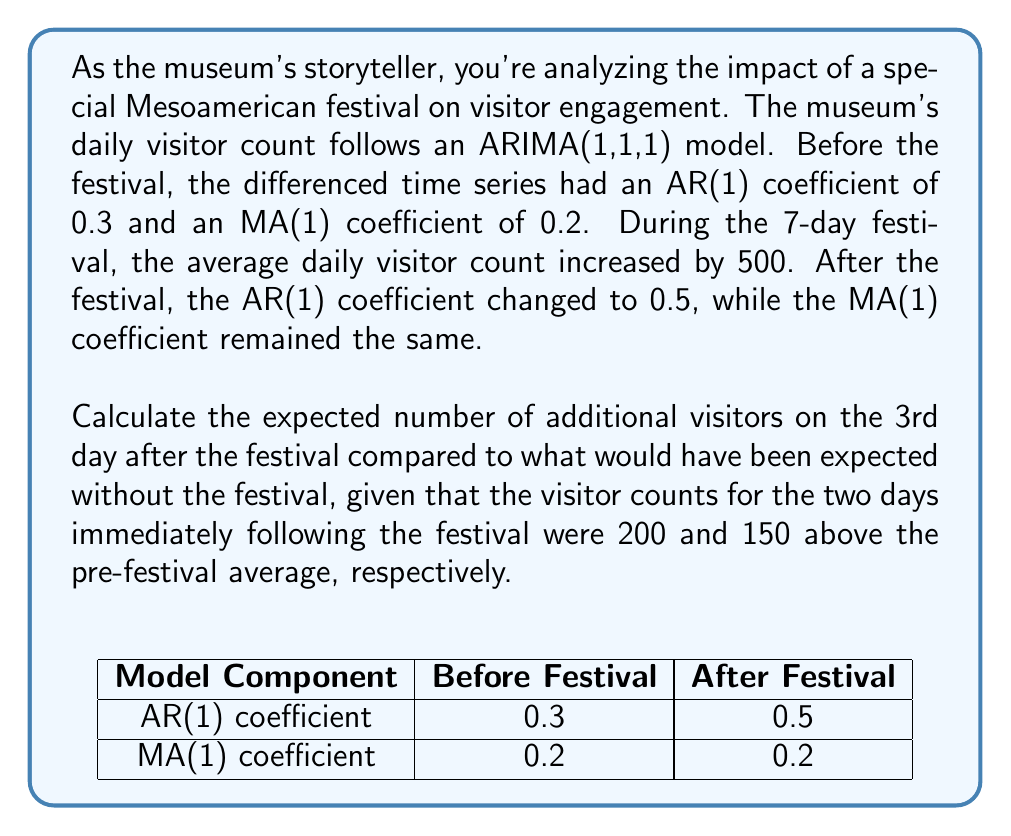Can you solve this math problem? Let's approach this step-by-step:

1) The ARIMA(1,1,1) model for the differenced series can be written as:
   $$(1 - \phi B)(1-B)X_t = (1 + \theta B)\epsilon_t$$
   where $\phi$ is the AR(1) coefficient, $\theta$ is the MA(1) coefficient, and $B$ is the backshift operator.

2) After the festival, $\phi = 0.5$ and $\theta = 0.2$. Let $Y_t = (1-B)X_t$ be the differenced series. Then:
   $$Y_t = 0.5Y_{t-1} + \epsilon_t + 0.2\epsilon_{t-1}$$

3) Let $Z_t$ be the number of additional visitors compared to the pre-festival average. Then $Z_t = Y_t + 500$ for the festival days, and we need to forecast $Z_3$.

4) We're given $Z_1 = 200$ and $Z_2 = 150$. We can use these to find $Y_1$ and $Y_2$:
   $Y_1 = Z_1 - 500 = -300$
   $Y_2 = Z_2 - 500 = -350$

5) Now we can forecast $Y_3$:
   $$E[Y_3] = 0.5Y_2 + 0.2\epsilon_2$$
   
   We don't know $\epsilon_2$, but we can estimate it:
   $$\epsilon_2 \approx Y_2 - 0.5Y_1 = -350 - 0.5(-300) = -200$$

   So, $E[Y_3] = 0.5(-350) + 0.2(-200) = -215$

6) Finally, we can calculate $E[Z_3]$:
   $$E[Z_3] = E[Y_3] + 500 = -215 + 500 = 285$$

Therefore, we expect 285 additional visitors on the 3rd day after the festival compared to what would have been expected without the festival.
Answer: 285 additional visitors 